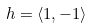<formula> <loc_0><loc_0><loc_500><loc_500>h = \langle 1 , - 1 \rangle</formula> 